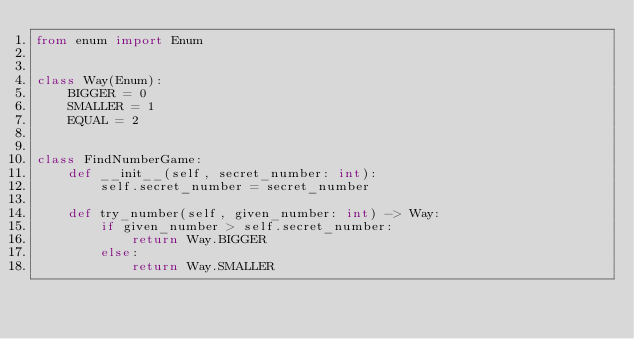Convert code to text. <code><loc_0><loc_0><loc_500><loc_500><_Python_>from enum import Enum


class Way(Enum):
    BIGGER = 0
    SMALLER = 1
    EQUAL = 2


class FindNumberGame:
    def __init__(self, secret_number: int):
        self.secret_number = secret_number

    def try_number(self, given_number: int) -> Way:
        if given_number > self.secret_number:
            return Way.BIGGER
        else:
            return Way.SMALLER
</code> 